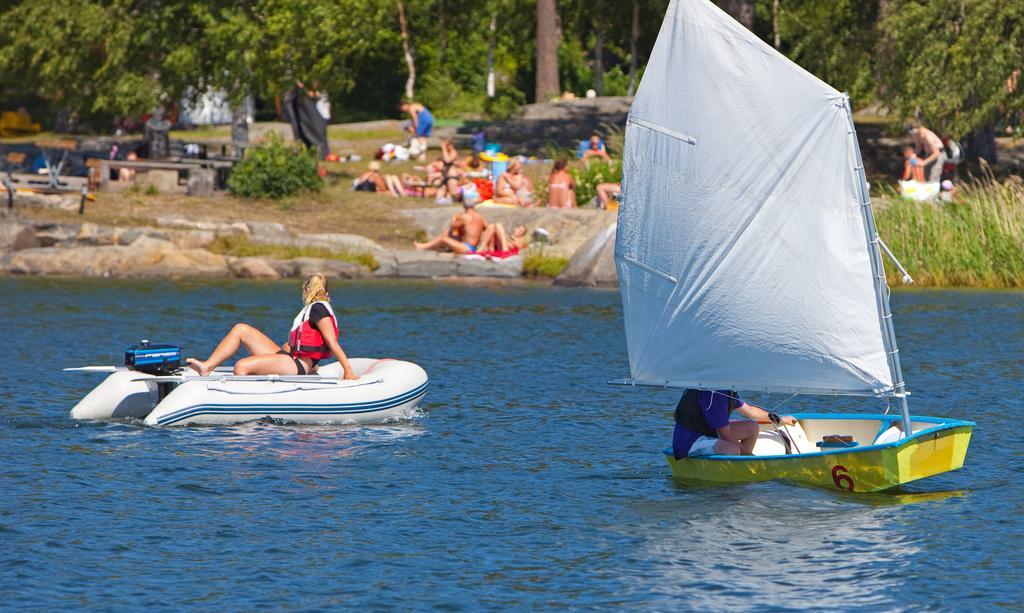Please provide a concise description of this image. In this image we can see boats on the water and two person in the boats, there are few people on the ground and there are few benches, trees and plants in the background. 